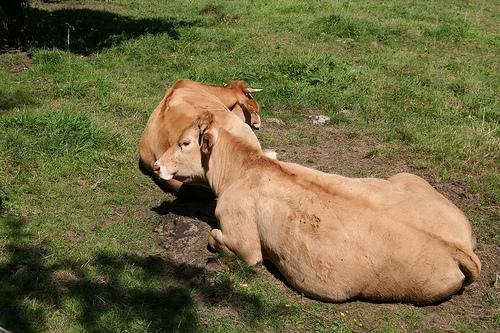Question: what is this a pic of?
Choices:
A. A happy couple.
B. Cows.
C. Children playing.
D. A baseball game.
Answer with the letter. Answer: B Question: what color are the cows?
Choices:
A. Black.
B. White.
C. Brown.
D. Tan.
Answer with the letter. Answer: D Question: how many shadows are in the pic?
Choices:
A. 2.
B. 6.
C. 12.
D. 3.
Answer with the letter. Answer: D Question: how many ears are visible?
Choices:
A. 4.
B. 3.
C. 6.
D. 2.
Answer with the letter. Answer: D Question: how many cows are there?
Choices:
A. 2.
B. 4.
C. 8.
D. 12.
Answer with the letter. Answer: A Question: why are the animals laying down?
Choices:
A. They are sleeping.
B. They are tired.
C. They are dead.
D. They are doing tricks.
Answer with the letter. Answer: B 